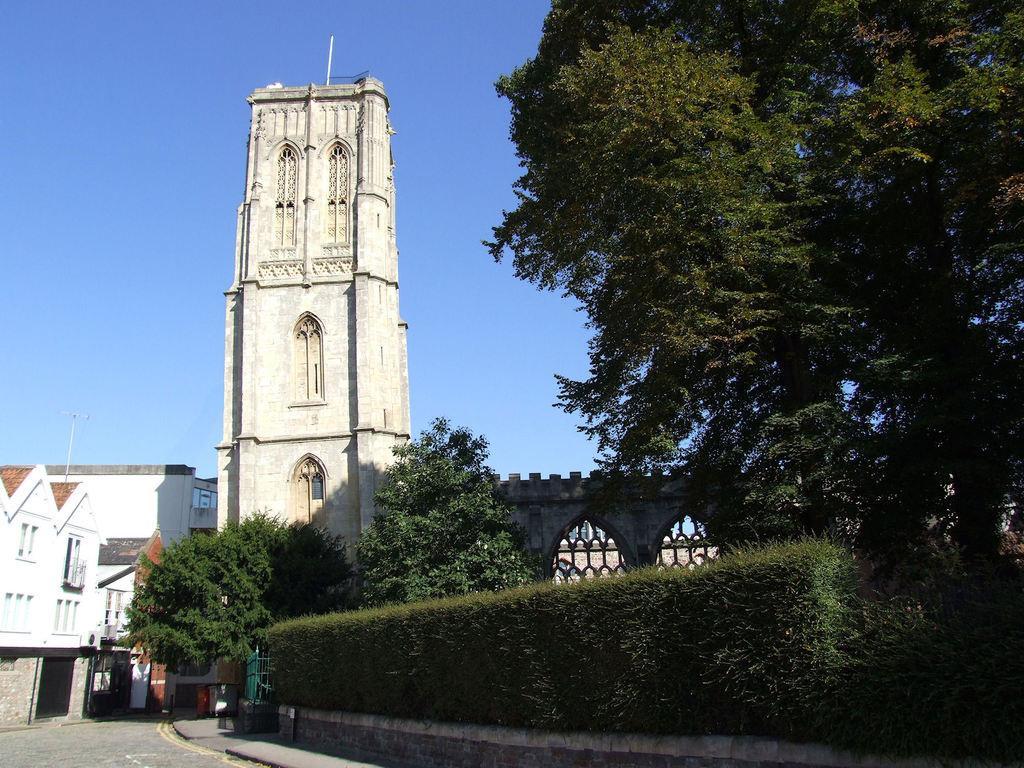Could you give a brief overview of what you see in this image? In this image we can see buildings and trees and also shrubs. Image also consists of a tower. At the top there is sky and at the bottom we can see the road. 